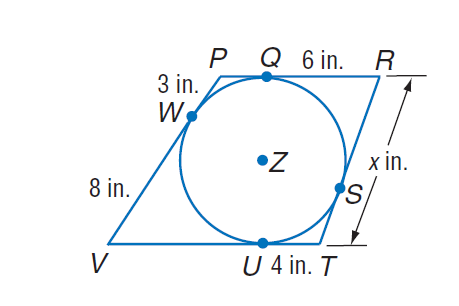Question: Find x. Assume that segments that appear to be tangent are tangent.
Choices:
A. 3
B. 6
C. 8
D. 10
Answer with the letter. Answer: D 